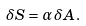Convert formula to latex. <formula><loc_0><loc_0><loc_500><loc_500>\delta S = \alpha \, \delta A .</formula> 